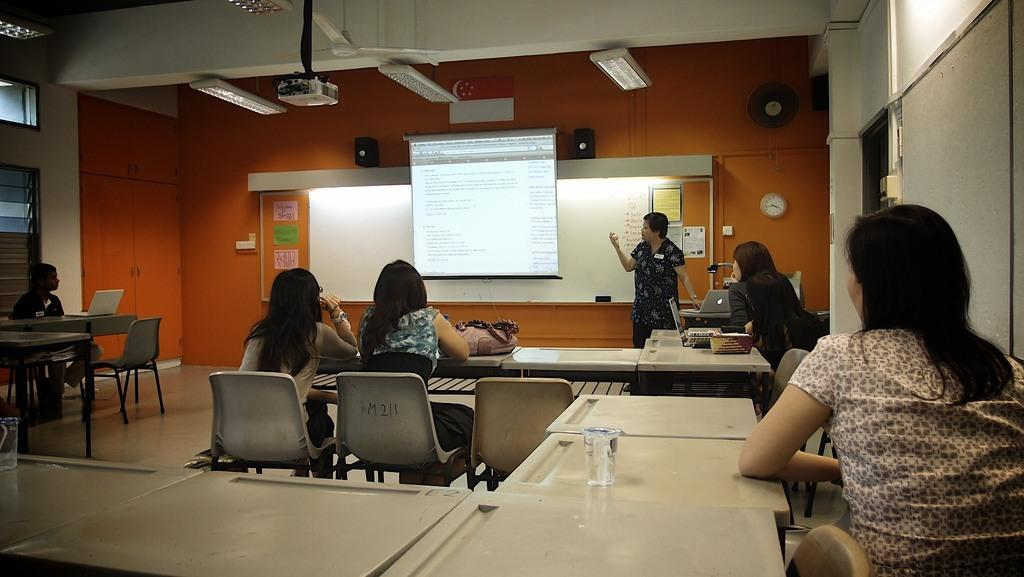What are the people in the image doing? There are people seated on chairs in the image, suggesting they might be attending a presentation or meeting. What is the woman in the image doing? The woman is standing and speaking in the image, which indicates she might be the presenter or speaker. What is the woman looking at while speaking? The woman is looking at a projector screen, which suggests she is presenting or showing information. What time-related object is visible in the image? There is a wall clock visible on a wall in the image. What device is used to display information on the projector screen? There is a projector present in the image, which is likely used to display information on the screen. How much friction is present between the woman's shoes and the floor in the image? There is no information provided about the friction between the woman's shoes and the floor in the image. Are there any brothers present in the image? There is no mention of brothers in the image, only people seated on chairs and a woman standing and speaking. 